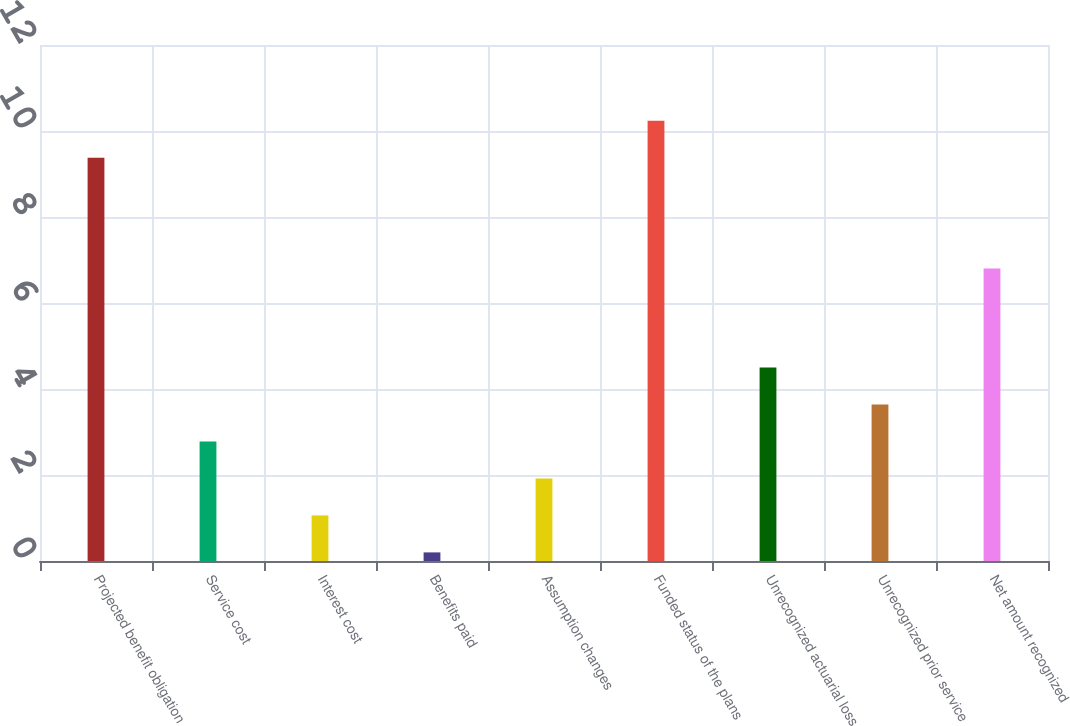<chart> <loc_0><loc_0><loc_500><loc_500><bar_chart><fcel>Projected benefit obligation<fcel>Service cost<fcel>Interest cost<fcel>Benefits paid<fcel>Assumption changes<fcel>Funded status of the plans<fcel>Unrecognized actuarial loss<fcel>Unrecognized prior service<fcel>Net amount recognized<nl><fcel>9.38<fcel>2.78<fcel>1.06<fcel>0.2<fcel>1.92<fcel>10.24<fcel>4.5<fcel>3.64<fcel>6.8<nl></chart> 